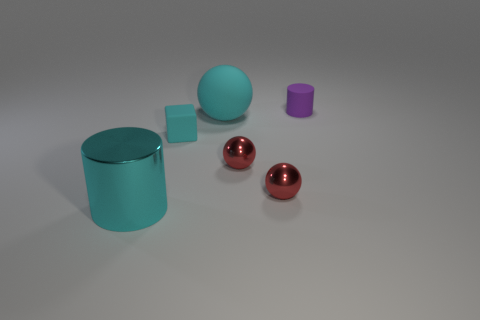Subtract all metallic spheres. How many spheres are left? 1 Subtract all purple blocks. How many red spheres are left? 2 Subtract all cyan spheres. How many spheres are left? 2 Subtract all brown spheres. Subtract all green cylinders. How many spheres are left? 3 Subtract all cylinders. How many objects are left? 4 Add 2 small cyan blocks. How many objects exist? 8 Add 6 small cylinders. How many small cylinders exist? 7 Subtract 0 red cylinders. How many objects are left? 6 Subtract all gray matte balls. Subtract all red objects. How many objects are left? 4 Add 6 cyan objects. How many cyan objects are left? 9 